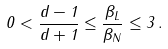Convert formula to latex. <formula><loc_0><loc_0><loc_500><loc_500>0 < \frac { d - 1 } { d + 1 } \leq \frac { \beta _ { L } } { \beta _ { N } } \leq 3 \, .</formula> 